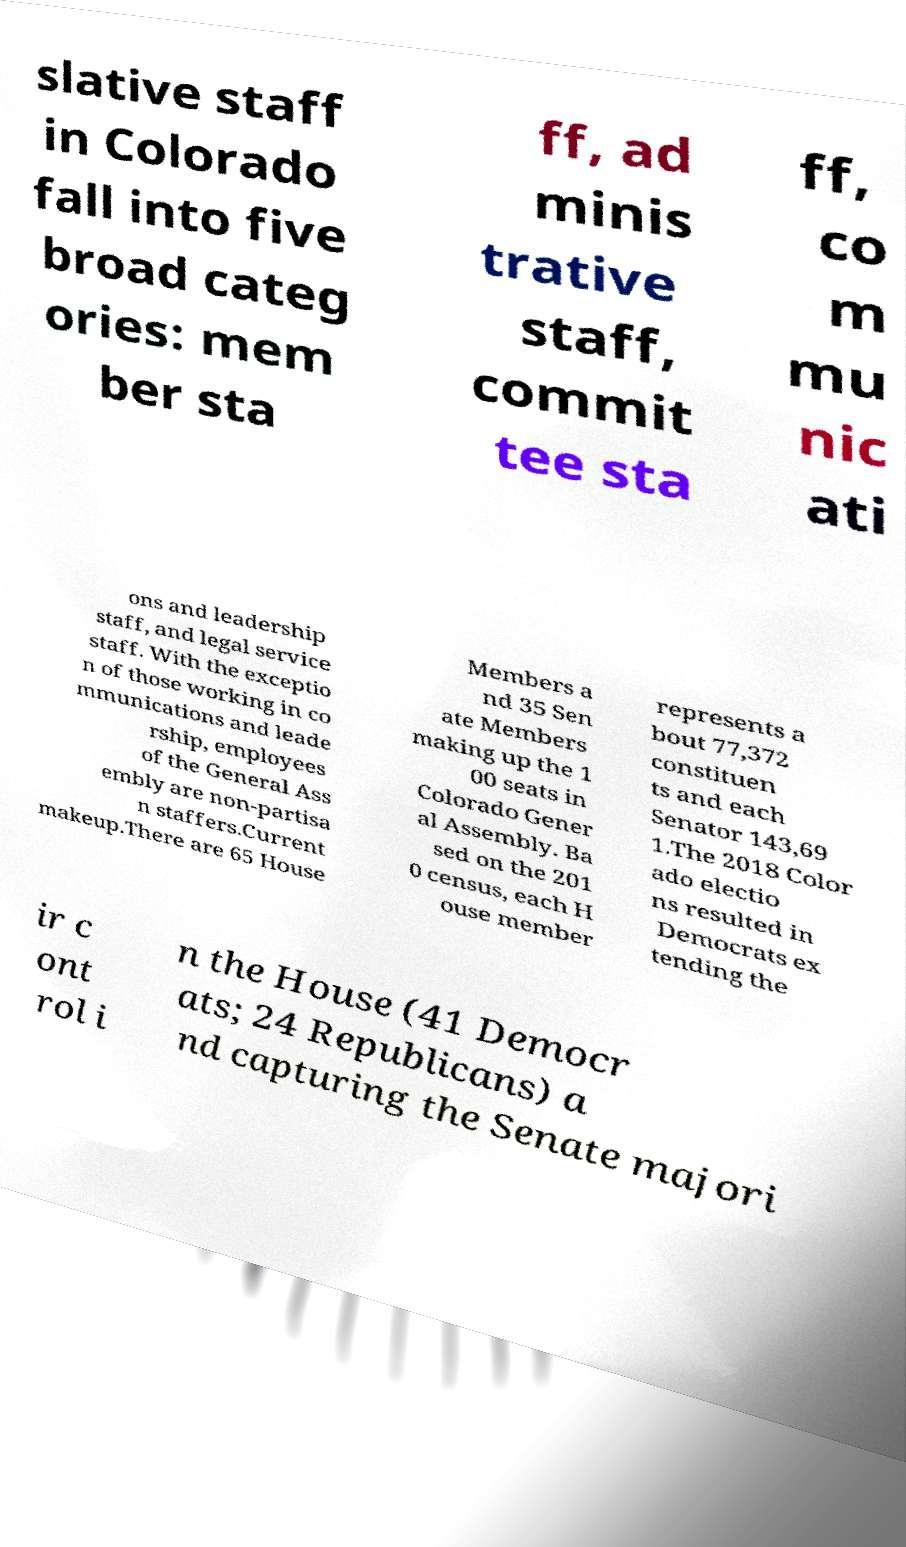For documentation purposes, I need the text within this image transcribed. Could you provide that? slative staff in Colorado fall into five broad categ ories: mem ber sta ff, ad minis trative staff, commit tee sta ff, co m mu nic ati ons and leadership staff, and legal service staff. With the exceptio n of those working in co mmunications and leade rship, employees of the General Ass embly are non-partisa n staffers.Current makeup.There are 65 House Members a nd 35 Sen ate Members making up the 1 00 seats in Colorado Gener al Assembly. Ba sed on the 201 0 census, each H ouse member represents a bout 77,372 constituen ts and each Senator 143,69 1.The 2018 Color ado electio ns resulted in Democrats ex tending the ir c ont rol i n the House (41 Democr ats; 24 Republicans) a nd capturing the Senate majori 